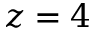<formula> <loc_0><loc_0><loc_500><loc_500>z = 4</formula> 